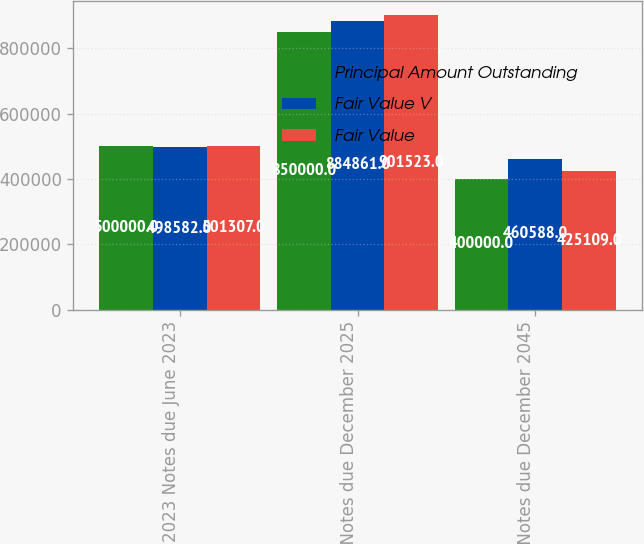Convert chart to OTSL. <chart><loc_0><loc_0><loc_500><loc_500><stacked_bar_chart><ecel><fcel>2023 Notes due June 2023<fcel>2025 Notes due December 2025<fcel>2045 Notes due December 2045<nl><fcel>Principal Amount Outstanding<fcel>500000<fcel>850000<fcel>400000<nl><fcel>Fair Value V<fcel>498582<fcel>884861<fcel>460588<nl><fcel>Fair Value<fcel>501307<fcel>901523<fcel>425109<nl></chart> 